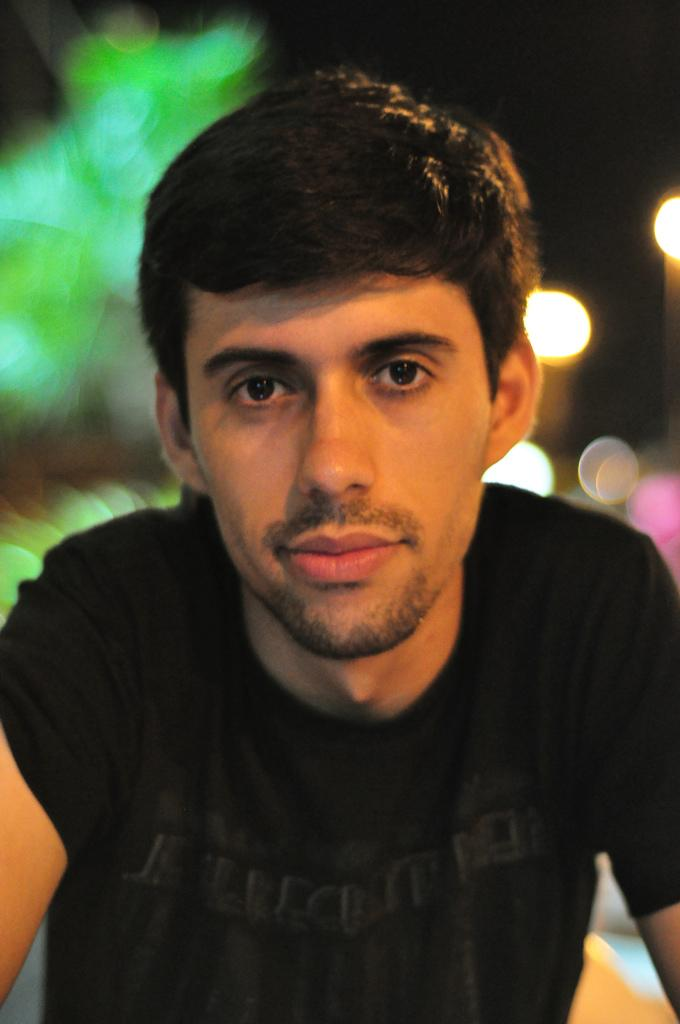Who is present in the image? There is a man present in the image. What is the man wearing? The man is wearing a black t-shirt. Can you describe the background of the image? The background of the image is blurry. What day of the week is depicted in the image? The day of the week is not depicted in the image, as it is a still photograph and does not show any specific day. 